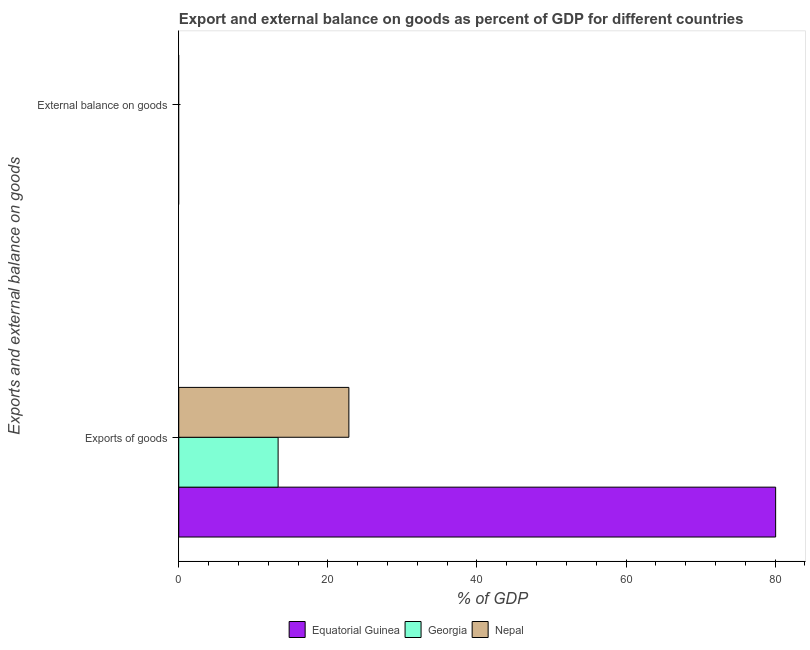What is the label of the 1st group of bars from the top?
Make the answer very short. External balance on goods. What is the external balance on goods as percentage of gdp in Equatorial Guinea?
Give a very brief answer. 0. Across all countries, what is the maximum export of goods as percentage of gdp?
Offer a terse response. 80.07. Across all countries, what is the minimum export of goods as percentage of gdp?
Provide a succinct answer. 13.33. In which country was the export of goods as percentage of gdp maximum?
Give a very brief answer. Equatorial Guinea. What is the total export of goods as percentage of gdp in the graph?
Make the answer very short. 116.21. What is the difference between the export of goods as percentage of gdp in Georgia and that in Equatorial Guinea?
Ensure brevity in your answer.  -66.74. What is the difference between the external balance on goods as percentage of gdp in Nepal and the export of goods as percentage of gdp in Equatorial Guinea?
Give a very brief answer. -80.07. What is the ratio of the export of goods as percentage of gdp in Georgia to that in Equatorial Guinea?
Your answer should be very brief. 0.17. How many bars are there?
Offer a very short reply. 3. Are all the bars in the graph horizontal?
Your answer should be compact. Yes. How many countries are there in the graph?
Your answer should be very brief. 3. What is the difference between two consecutive major ticks on the X-axis?
Make the answer very short. 20. Are the values on the major ticks of X-axis written in scientific E-notation?
Offer a terse response. No. Does the graph contain any zero values?
Ensure brevity in your answer.  Yes. What is the title of the graph?
Offer a very short reply. Export and external balance on goods as percent of GDP for different countries. What is the label or title of the X-axis?
Keep it short and to the point. % of GDP. What is the label or title of the Y-axis?
Offer a terse response. Exports and external balance on goods. What is the % of GDP in Equatorial Guinea in Exports of goods?
Ensure brevity in your answer.  80.07. What is the % of GDP of Georgia in Exports of goods?
Offer a very short reply. 13.33. What is the % of GDP of Nepal in Exports of goods?
Offer a terse response. 22.82. What is the % of GDP of Georgia in External balance on goods?
Make the answer very short. 0. What is the % of GDP of Nepal in External balance on goods?
Offer a very short reply. 0. Across all Exports and external balance on goods, what is the maximum % of GDP of Equatorial Guinea?
Offer a very short reply. 80.07. Across all Exports and external balance on goods, what is the maximum % of GDP in Georgia?
Keep it short and to the point. 13.33. Across all Exports and external balance on goods, what is the maximum % of GDP in Nepal?
Offer a terse response. 22.82. What is the total % of GDP in Equatorial Guinea in the graph?
Ensure brevity in your answer.  80.07. What is the total % of GDP of Georgia in the graph?
Your answer should be very brief. 13.33. What is the total % of GDP in Nepal in the graph?
Offer a terse response. 22.82. What is the average % of GDP in Equatorial Guinea per Exports and external balance on goods?
Ensure brevity in your answer.  40.03. What is the average % of GDP in Georgia per Exports and external balance on goods?
Ensure brevity in your answer.  6.66. What is the average % of GDP in Nepal per Exports and external balance on goods?
Ensure brevity in your answer.  11.41. What is the difference between the % of GDP of Equatorial Guinea and % of GDP of Georgia in Exports of goods?
Provide a succinct answer. 66.74. What is the difference between the % of GDP of Equatorial Guinea and % of GDP of Nepal in Exports of goods?
Your response must be concise. 57.25. What is the difference between the % of GDP in Georgia and % of GDP in Nepal in Exports of goods?
Your answer should be very brief. -9.49. What is the difference between the highest and the lowest % of GDP of Equatorial Guinea?
Provide a succinct answer. 80.07. What is the difference between the highest and the lowest % of GDP of Georgia?
Your answer should be compact. 13.33. What is the difference between the highest and the lowest % of GDP of Nepal?
Provide a short and direct response. 22.82. 